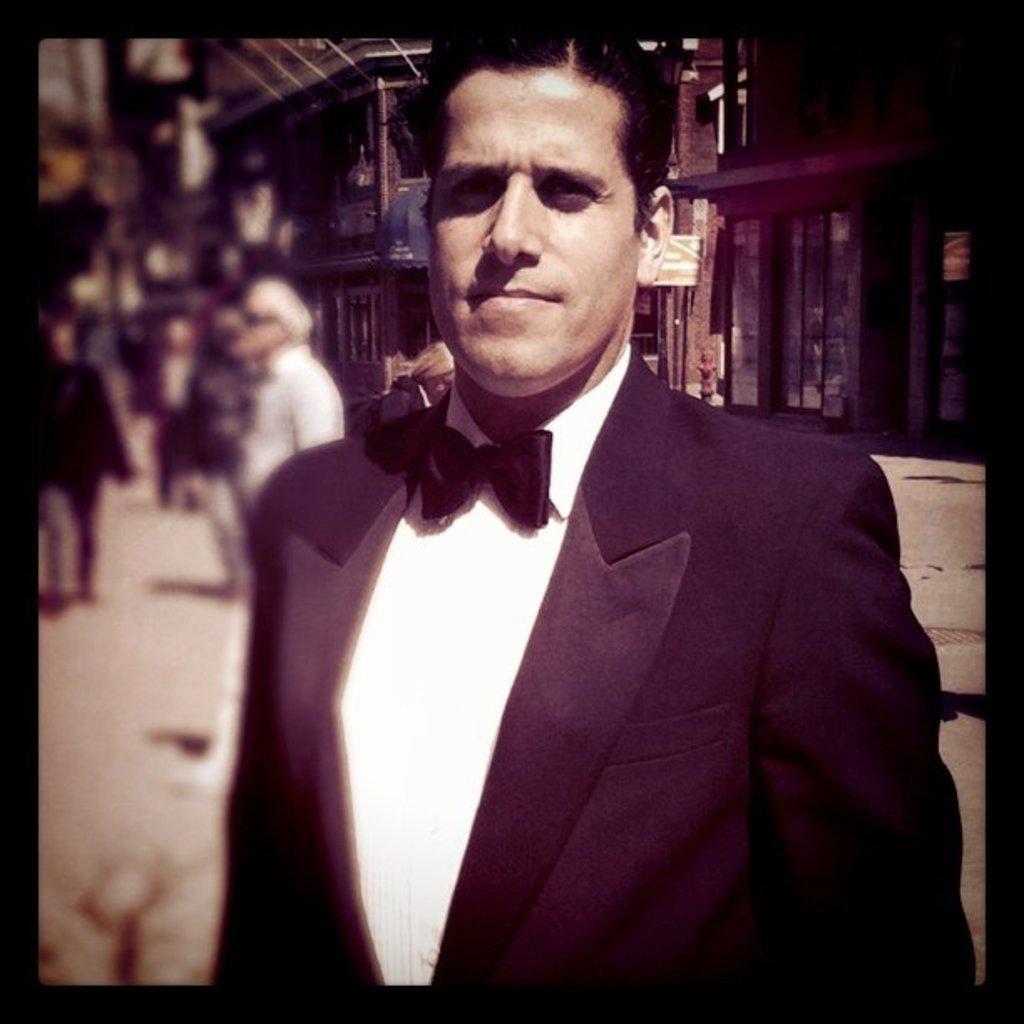Can you describe this image briefly? In this picture there is a man who is wearing a suit. In the back I can see the building. On the left I can see some people who are standing on the street. 